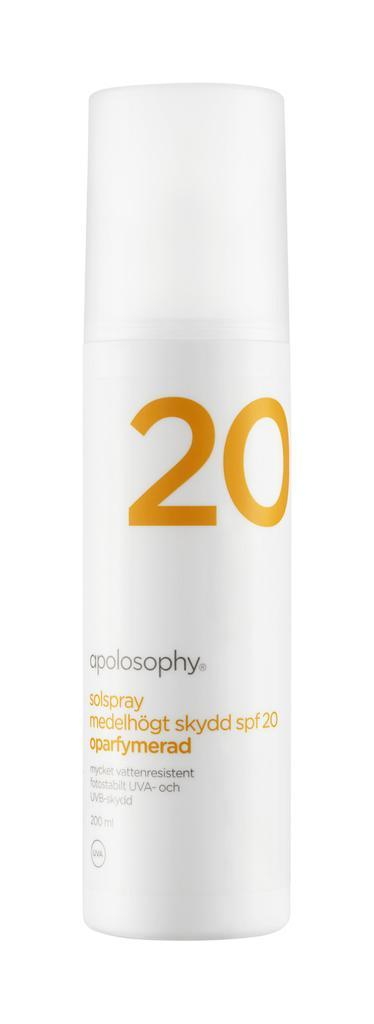What object is white and can be seen in the image? There is a white spray bottle in the image. What feature is present on the spray bottle? The spray bottle has a number on it. What type of information is written on the spray bottle? There is black text on the spray bottle. What type of machine is depicted in the image? There is no machine present in the image; it features a white spray bottle. 